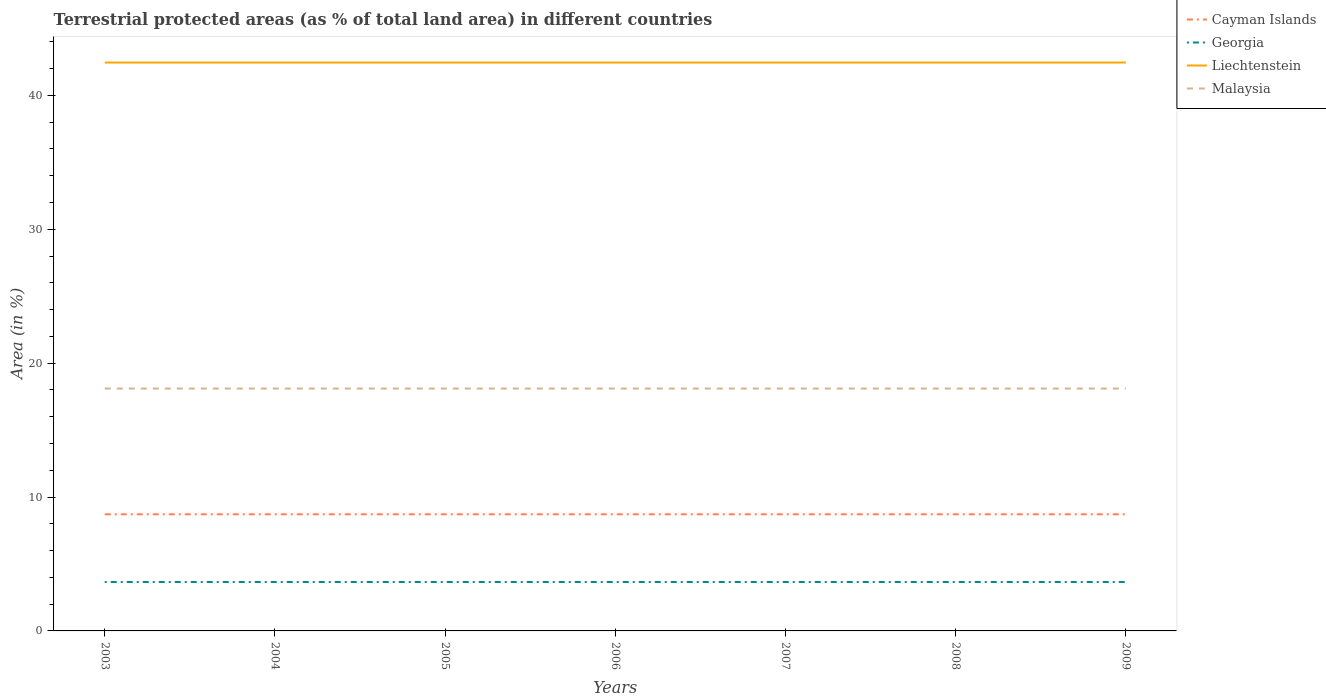Does the line corresponding to Malaysia intersect with the line corresponding to Georgia?
Provide a short and direct response. No. Across all years, what is the maximum percentage of terrestrial protected land in Malaysia?
Provide a succinct answer. 18.1. In which year was the percentage of terrestrial protected land in Georgia maximum?
Your response must be concise. 2003. Is the percentage of terrestrial protected land in Malaysia strictly greater than the percentage of terrestrial protected land in Cayman Islands over the years?
Offer a terse response. No. How many years are there in the graph?
Provide a succinct answer. 7. Does the graph contain any zero values?
Give a very brief answer. No. Does the graph contain grids?
Ensure brevity in your answer.  No. How are the legend labels stacked?
Provide a succinct answer. Vertical. What is the title of the graph?
Ensure brevity in your answer.  Terrestrial protected areas (as % of total land area) in different countries. What is the label or title of the X-axis?
Make the answer very short. Years. What is the label or title of the Y-axis?
Offer a terse response. Area (in %). What is the Area (in %) in Cayman Islands in 2003?
Make the answer very short. 8.71. What is the Area (in %) of Georgia in 2003?
Provide a short and direct response. 3.65. What is the Area (in %) of Liechtenstein in 2003?
Make the answer very short. 42.45. What is the Area (in %) of Malaysia in 2003?
Your response must be concise. 18.1. What is the Area (in %) of Cayman Islands in 2004?
Your answer should be very brief. 8.71. What is the Area (in %) of Georgia in 2004?
Provide a succinct answer. 3.65. What is the Area (in %) of Liechtenstein in 2004?
Give a very brief answer. 42.45. What is the Area (in %) in Malaysia in 2004?
Your answer should be very brief. 18.1. What is the Area (in %) in Cayman Islands in 2005?
Give a very brief answer. 8.71. What is the Area (in %) in Georgia in 2005?
Offer a very short reply. 3.65. What is the Area (in %) in Liechtenstein in 2005?
Provide a short and direct response. 42.45. What is the Area (in %) of Malaysia in 2005?
Give a very brief answer. 18.1. What is the Area (in %) in Cayman Islands in 2006?
Your answer should be very brief. 8.71. What is the Area (in %) in Georgia in 2006?
Provide a succinct answer. 3.65. What is the Area (in %) of Liechtenstein in 2006?
Provide a short and direct response. 42.45. What is the Area (in %) of Malaysia in 2006?
Ensure brevity in your answer.  18.1. What is the Area (in %) of Cayman Islands in 2007?
Ensure brevity in your answer.  8.71. What is the Area (in %) in Georgia in 2007?
Keep it short and to the point. 3.65. What is the Area (in %) of Liechtenstein in 2007?
Your answer should be very brief. 42.45. What is the Area (in %) in Malaysia in 2007?
Provide a short and direct response. 18.1. What is the Area (in %) in Cayman Islands in 2008?
Your answer should be very brief. 8.71. What is the Area (in %) in Georgia in 2008?
Give a very brief answer. 3.65. What is the Area (in %) of Liechtenstein in 2008?
Provide a short and direct response. 42.45. What is the Area (in %) of Malaysia in 2008?
Provide a short and direct response. 18.1. What is the Area (in %) of Cayman Islands in 2009?
Make the answer very short. 8.71. What is the Area (in %) in Georgia in 2009?
Make the answer very short. 3.65. What is the Area (in %) in Liechtenstein in 2009?
Give a very brief answer. 42.45. What is the Area (in %) of Malaysia in 2009?
Ensure brevity in your answer.  18.1. Across all years, what is the maximum Area (in %) of Cayman Islands?
Ensure brevity in your answer.  8.71. Across all years, what is the maximum Area (in %) of Georgia?
Make the answer very short. 3.65. Across all years, what is the maximum Area (in %) of Liechtenstein?
Your answer should be compact. 42.45. Across all years, what is the maximum Area (in %) in Malaysia?
Ensure brevity in your answer.  18.1. Across all years, what is the minimum Area (in %) of Cayman Islands?
Make the answer very short. 8.71. Across all years, what is the minimum Area (in %) of Georgia?
Offer a terse response. 3.65. Across all years, what is the minimum Area (in %) in Liechtenstein?
Provide a succinct answer. 42.45. Across all years, what is the minimum Area (in %) of Malaysia?
Make the answer very short. 18.1. What is the total Area (in %) in Cayman Islands in the graph?
Your answer should be compact. 60.97. What is the total Area (in %) of Georgia in the graph?
Ensure brevity in your answer.  25.57. What is the total Area (in %) of Liechtenstein in the graph?
Your answer should be compact. 297.15. What is the total Area (in %) in Malaysia in the graph?
Ensure brevity in your answer.  126.72. What is the difference between the Area (in %) of Cayman Islands in 2003 and that in 2004?
Give a very brief answer. 0. What is the difference between the Area (in %) in Georgia in 2003 and that in 2004?
Make the answer very short. 0. What is the difference between the Area (in %) of Cayman Islands in 2003 and that in 2005?
Provide a succinct answer. 0. What is the difference between the Area (in %) of Liechtenstein in 2003 and that in 2005?
Ensure brevity in your answer.  0. What is the difference between the Area (in %) in Malaysia in 2003 and that in 2005?
Provide a short and direct response. 0. What is the difference between the Area (in %) of Cayman Islands in 2003 and that in 2006?
Offer a terse response. 0. What is the difference between the Area (in %) in Georgia in 2003 and that in 2006?
Keep it short and to the point. 0. What is the difference between the Area (in %) in Malaysia in 2003 and that in 2006?
Make the answer very short. 0. What is the difference between the Area (in %) in Cayman Islands in 2003 and that in 2007?
Your answer should be compact. 0. What is the difference between the Area (in %) in Liechtenstein in 2003 and that in 2007?
Your answer should be very brief. 0. What is the difference between the Area (in %) in Malaysia in 2003 and that in 2007?
Give a very brief answer. 0. What is the difference between the Area (in %) in Cayman Islands in 2003 and that in 2008?
Your answer should be very brief. 0. What is the difference between the Area (in %) of Georgia in 2003 and that in 2008?
Make the answer very short. 0. What is the difference between the Area (in %) in Malaysia in 2003 and that in 2008?
Provide a short and direct response. 0. What is the difference between the Area (in %) of Georgia in 2003 and that in 2009?
Provide a short and direct response. 0. What is the difference between the Area (in %) of Cayman Islands in 2004 and that in 2005?
Make the answer very short. 0. What is the difference between the Area (in %) of Liechtenstein in 2004 and that in 2005?
Offer a terse response. 0. What is the difference between the Area (in %) in Georgia in 2004 and that in 2006?
Make the answer very short. 0. What is the difference between the Area (in %) of Liechtenstein in 2004 and that in 2006?
Your answer should be compact. 0. What is the difference between the Area (in %) in Liechtenstein in 2004 and that in 2007?
Your answer should be compact. 0. What is the difference between the Area (in %) in Cayman Islands in 2004 and that in 2008?
Provide a short and direct response. 0. What is the difference between the Area (in %) of Liechtenstein in 2004 and that in 2008?
Offer a very short reply. 0. What is the difference between the Area (in %) in Malaysia in 2004 and that in 2008?
Provide a succinct answer. 0. What is the difference between the Area (in %) of Malaysia in 2004 and that in 2009?
Your response must be concise. 0. What is the difference between the Area (in %) of Georgia in 2005 and that in 2006?
Provide a succinct answer. 0. What is the difference between the Area (in %) of Malaysia in 2005 and that in 2006?
Offer a very short reply. 0. What is the difference between the Area (in %) in Cayman Islands in 2005 and that in 2007?
Your answer should be compact. 0. What is the difference between the Area (in %) of Georgia in 2005 and that in 2007?
Offer a very short reply. 0. What is the difference between the Area (in %) in Malaysia in 2005 and that in 2007?
Provide a succinct answer. 0. What is the difference between the Area (in %) in Cayman Islands in 2005 and that in 2008?
Keep it short and to the point. 0. What is the difference between the Area (in %) of Georgia in 2005 and that in 2008?
Make the answer very short. 0. What is the difference between the Area (in %) of Liechtenstein in 2005 and that in 2008?
Make the answer very short. 0. What is the difference between the Area (in %) in Malaysia in 2005 and that in 2008?
Your response must be concise. 0. What is the difference between the Area (in %) of Georgia in 2005 and that in 2009?
Give a very brief answer. 0. What is the difference between the Area (in %) of Liechtenstein in 2005 and that in 2009?
Provide a short and direct response. 0. What is the difference between the Area (in %) of Malaysia in 2005 and that in 2009?
Keep it short and to the point. 0. What is the difference between the Area (in %) of Cayman Islands in 2006 and that in 2007?
Your response must be concise. 0. What is the difference between the Area (in %) in Georgia in 2006 and that in 2008?
Your answer should be very brief. 0. What is the difference between the Area (in %) in Georgia in 2006 and that in 2009?
Keep it short and to the point. 0. What is the difference between the Area (in %) of Liechtenstein in 2006 and that in 2009?
Your answer should be compact. 0. What is the difference between the Area (in %) in Malaysia in 2006 and that in 2009?
Ensure brevity in your answer.  0. What is the difference between the Area (in %) in Cayman Islands in 2007 and that in 2008?
Provide a succinct answer. 0. What is the difference between the Area (in %) of Liechtenstein in 2007 and that in 2008?
Offer a terse response. 0. What is the difference between the Area (in %) in Cayman Islands in 2007 and that in 2009?
Your response must be concise. 0. What is the difference between the Area (in %) in Liechtenstein in 2008 and that in 2009?
Ensure brevity in your answer.  0. What is the difference between the Area (in %) in Malaysia in 2008 and that in 2009?
Offer a terse response. 0. What is the difference between the Area (in %) of Cayman Islands in 2003 and the Area (in %) of Georgia in 2004?
Provide a succinct answer. 5.06. What is the difference between the Area (in %) of Cayman Islands in 2003 and the Area (in %) of Liechtenstein in 2004?
Keep it short and to the point. -33.74. What is the difference between the Area (in %) of Cayman Islands in 2003 and the Area (in %) of Malaysia in 2004?
Ensure brevity in your answer.  -9.39. What is the difference between the Area (in %) of Georgia in 2003 and the Area (in %) of Liechtenstein in 2004?
Ensure brevity in your answer.  -38.8. What is the difference between the Area (in %) of Georgia in 2003 and the Area (in %) of Malaysia in 2004?
Make the answer very short. -14.45. What is the difference between the Area (in %) of Liechtenstein in 2003 and the Area (in %) of Malaysia in 2004?
Your response must be concise. 24.35. What is the difference between the Area (in %) in Cayman Islands in 2003 and the Area (in %) in Georgia in 2005?
Make the answer very short. 5.06. What is the difference between the Area (in %) in Cayman Islands in 2003 and the Area (in %) in Liechtenstein in 2005?
Ensure brevity in your answer.  -33.74. What is the difference between the Area (in %) in Cayman Islands in 2003 and the Area (in %) in Malaysia in 2005?
Provide a short and direct response. -9.39. What is the difference between the Area (in %) of Georgia in 2003 and the Area (in %) of Liechtenstein in 2005?
Give a very brief answer. -38.8. What is the difference between the Area (in %) of Georgia in 2003 and the Area (in %) of Malaysia in 2005?
Provide a short and direct response. -14.45. What is the difference between the Area (in %) of Liechtenstein in 2003 and the Area (in %) of Malaysia in 2005?
Keep it short and to the point. 24.35. What is the difference between the Area (in %) in Cayman Islands in 2003 and the Area (in %) in Georgia in 2006?
Keep it short and to the point. 5.06. What is the difference between the Area (in %) of Cayman Islands in 2003 and the Area (in %) of Liechtenstein in 2006?
Offer a very short reply. -33.74. What is the difference between the Area (in %) in Cayman Islands in 2003 and the Area (in %) in Malaysia in 2006?
Your answer should be very brief. -9.39. What is the difference between the Area (in %) of Georgia in 2003 and the Area (in %) of Liechtenstein in 2006?
Provide a short and direct response. -38.8. What is the difference between the Area (in %) of Georgia in 2003 and the Area (in %) of Malaysia in 2006?
Give a very brief answer. -14.45. What is the difference between the Area (in %) of Liechtenstein in 2003 and the Area (in %) of Malaysia in 2006?
Your answer should be very brief. 24.35. What is the difference between the Area (in %) in Cayman Islands in 2003 and the Area (in %) in Georgia in 2007?
Provide a short and direct response. 5.06. What is the difference between the Area (in %) of Cayman Islands in 2003 and the Area (in %) of Liechtenstein in 2007?
Provide a short and direct response. -33.74. What is the difference between the Area (in %) of Cayman Islands in 2003 and the Area (in %) of Malaysia in 2007?
Provide a succinct answer. -9.39. What is the difference between the Area (in %) of Georgia in 2003 and the Area (in %) of Liechtenstein in 2007?
Your response must be concise. -38.8. What is the difference between the Area (in %) of Georgia in 2003 and the Area (in %) of Malaysia in 2007?
Keep it short and to the point. -14.45. What is the difference between the Area (in %) of Liechtenstein in 2003 and the Area (in %) of Malaysia in 2007?
Your answer should be compact. 24.35. What is the difference between the Area (in %) in Cayman Islands in 2003 and the Area (in %) in Georgia in 2008?
Provide a short and direct response. 5.06. What is the difference between the Area (in %) of Cayman Islands in 2003 and the Area (in %) of Liechtenstein in 2008?
Provide a short and direct response. -33.74. What is the difference between the Area (in %) of Cayman Islands in 2003 and the Area (in %) of Malaysia in 2008?
Your answer should be very brief. -9.39. What is the difference between the Area (in %) in Georgia in 2003 and the Area (in %) in Liechtenstein in 2008?
Provide a short and direct response. -38.8. What is the difference between the Area (in %) in Georgia in 2003 and the Area (in %) in Malaysia in 2008?
Keep it short and to the point. -14.45. What is the difference between the Area (in %) in Liechtenstein in 2003 and the Area (in %) in Malaysia in 2008?
Your answer should be compact. 24.35. What is the difference between the Area (in %) in Cayman Islands in 2003 and the Area (in %) in Georgia in 2009?
Your answer should be very brief. 5.06. What is the difference between the Area (in %) of Cayman Islands in 2003 and the Area (in %) of Liechtenstein in 2009?
Your response must be concise. -33.74. What is the difference between the Area (in %) in Cayman Islands in 2003 and the Area (in %) in Malaysia in 2009?
Offer a terse response. -9.39. What is the difference between the Area (in %) in Georgia in 2003 and the Area (in %) in Liechtenstein in 2009?
Offer a very short reply. -38.8. What is the difference between the Area (in %) of Georgia in 2003 and the Area (in %) of Malaysia in 2009?
Ensure brevity in your answer.  -14.45. What is the difference between the Area (in %) of Liechtenstein in 2003 and the Area (in %) of Malaysia in 2009?
Your answer should be very brief. 24.35. What is the difference between the Area (in %) in Cayman Islands in 2004 and the Area (in %) in Georgia in 2005?
Your answer should be compact. 5.06. What is the difference between the Area (in %) of Cayman Islands in 2004 and the Area (in %) of Liechtenstein in 2005?
Your answer should be compact. -33.74. What is the difference between the Area (in %) of Cayman Islands in 2004 and the Area (in %) of Malaysia in 2005?
Give a very brief answer. -9.39. What is the difference between the Area (in %) of Georgia in 2004 and the Area (in %) of Liechtenstein in 2005?
Provide a short and direct response. -38.8. What is the difference between the Area (in %) of Georgia in 2004 and the Area (in %) of Malaysia in 2005?
Make the answer very short. -14.45. What is the difference between the Area (in %) of Liechtenstein in 2004 and the Area (in %) of Malaysia in 2005?
Provide a short and direct response. 24.35. What is the difference between the Area (in %) in Cayman Islands in 2004 and the Area (in %) in Georgia in 2006?
Provide a succinct answer. 5.06. What is the difference between the Area (in %) of Cayman Islands in 2004 and the Area (in %) of Liechtenstein in 2006?
Make the answer very short. -33.74. What is the difference between the Area (in %) of Cayman Islands in 2004 and the Area (in %) of Malaysia in 2006?
Keep it short and to the point. -9.39. What is the difference between the Area (in %) in Georgia in 2004 and the Area (in %) in Liechtenstein in 2006?
Make the answer very short. -38.8. What is the difference between the Area (in %) in Georgia in 2004 and the Area (in %) in Malaysia in 2006?
Your response must be concise. -14.45. What is the difference between the Area (in %) in Liechtenstein in 2004 and the Area (in %) in Malaysia in 2006?
Offer a terse response. 24.35. What is the difference between the Area (in %) of Cayman Islands in 2004 and the Area (in %) of Georgia in 2007?
Ensure brevity in your answer.  5.06. What is the difference between the Area (in %) of Cayman Islands in 2004 and the Area (in %) of Liechtenstein in 2007?
Keep it short and to the point. -33.74. What is the difference between the Area (in %) of Cayman Islands in 2004 and the Area (in %) of Malaysia in 2007?
Your answer should be very brief. -9.39. What is the difference between the Area (in %) in Georgia in 2004 and the Area (in %) in Liechtenstein in 2007?
Give a very brief answer. -38.8. What is the difference between the Area (in %) of Georgia in 2004 and the Area (in %) of Malaysia in 2007?
Offer a very short reply. -14.45. What is the difference between the Area (in %) of Liechtenstein in 2004 and the Area (in %) of Malaysia in 2007?
Make the answer very short. 24.35. What is the difference between the Area (in %) in Cayman Islands in 2004 and the Area (in %) in Georgia in 2008?
Your answer should be compact. 5.06. What is the difference between the Area (in %) of Cayman Islands in 2004 and the Area (in %) of Liechtenstein in 2008?
Ensure brevity in your answer.  -33.74. What is the difference between the Area (in %) in Cayman Islands in 2004 and the Area (in %) in Malaysia in 2008?
Offer a terse response. -9.39. What is the difference between the Area (in %) of Georgia in 2004 and the Area (in %) of Liechtenstein in 2008?
Provide a succinct answer. -38.8. What is the difference between the Area (in %) in Georgia in 2004 and the Area (in %) in Malaysia in 2008?
Your answer should be compact. -14.45. What is the difference between the Area (in %) in Liechtenstein in 2004 and the Area (in %) in Malaysia in 2008?
Keep it short and to the point. 24.35. What is the difference between the Area (in %) in Cayman Islands in 2004 and the Area (in %) in Georgia in 2009?
Your answer should be compact. 5.06. What is the difference between the Area (in %) of Cayman Islands in 2004 and the Area (in %) of Liechtenstein in 2009?
Keep it short and to the point. -33.74. What is the difference between the Area (in %) in Cayman Islands in 2004 and the Area (in %) in Malaysia in 2009?
Make the answer very short. -9.39. What is the difference between the Area (in %) in Georgia in 2004 and the Area (in %) in Liechtenstein in 2009?
Ensure brevity in your answer.  -38.8. What is the difference between the Area (in %) of Georgia in 2004 and the Area (in %) of Malaysia in 2009?
Offer a very short reply. -14.45. What is the difference between the Area (in %) of Liechtenstein in 2004 and the Area (in %) of Malaysia in 2009?
Make the answer very short. 24.35. What is the difference between the Area (in %) in Cayman Islands in 2005 and the Area (in %) in Georgia in 2006?
Your answer should be compact. 5.06. What is the difference between the Area (in %) of Cayman Islands in 2005 and the Area (in %) of Liechtenstein in 2006?
Provide a succinct answer. -33.74. What is the difference between the Area (in %) in Cayman Islands in 2005 and the Area (in %) in Malaysia in 2006?
Provide a succinct answer. -9.39. What is the difference between the Area (in %) of Georgia in 2005 and the Area (in %) of Liechtenstein in 2006?
Provide a succinct answer. -38.8. What is the difference between the Area (in %) of Georgia in 2005 and the Area (in %) of Malaysia in 2006?
Give a very brief answer. -14.45. What is the difference between the Area (in %) in Liechtenstein in 2005 and the Area (in %) in Malaysia in 2006?
Your answer should be very brief. 24.35. What is the difference between the Area (in %) of Cayman Islands in 2005 and the Area (in %) of Georgia in 2007?
Your answer should be compact. 5.06. What is the difference between the Area (in %) of Cayman Islands in 2005 and the Area (in %) of Liechtenstein in 2007?
Your response must be concise. -33.74. What is the difference between the Area (in %) of Cayman Islands in 2005 and the Area (in %) of Malaysia in 2007?
Offer a very short reply. -9.39. What is the difference between the Area (in %) of Georgia in 2005 and the Area (in %) of Liechtenstein in 2007?
Your answer should be very brief. -38.8. What is the difference between the Area (in %) in Georgia in 2005 and the Area (in %) in Malaysia in 2007?
Ensure brevity in your answer.  -14.45. What is the difference between the Area (in %) in Liechtenstein in 2005 and the Area (in %) in Malaysia in 2007?
Your answer should be compact. 24.35. What is the difference between the Area (in %) in Cayman Islands in 2005 and the Area (in %) in Georgia in 2008?
Keep it short and to the point. 5.06. What is the difference between the Area (in %) in Cayman Islands in 2005 and the Area (in %) in Liechtenstein in 2008?
Make the answer very short. -33.74. What is the difference between the Area (in %) of Cayman Islands in 2005 and the Area (in %) of Malaysia in 2008?
Make the answer very short. -9.39. What is the difference between the Area (in %) of Georgia in 2005 and the Area (in %) of Liechtenstein in 2008?
Give a very brief answer. -38.8. What is the difference between the Area (in %) in Georgia in 2005 and the Area (in %) in Malaysia in 2008?
Provide a short and direct response. -14.45. What is the difference between the Area (in %) in Liechtenstein in 2005 and the Area (in %) in Malaysia in 2008?
Your answer should be compact. 24.35. What is the difference between the Area (in %) of Cayman Islands in 2005 and the Area (in %) of Georgia in 2009?
Your answer should be compact. 5.06. What is the difference between the Area (in %) of Cayman Islands in 2005 and the Area (in %) of Liechtenstein in 2009?
Provide a short and direct response. -33.74. What is the difference between the Area (in %) of Cayman Islands in 2005 and the Area (in %) of Malaysia in 2009?
Give a very brief answer. -9.39. What is the difference between the Area (in %) in Georgia in 2005 and the Area (in %) in Liechtenstein in 2009?
Provide a short and direct response. -38.8. What is the difference between the Area (in %) in Georgia in 2005 and the Area (in %) in Malaysia in 2009?
Your answer should be compact. -14.45. What is the difference between the Area (in %) in Liechtenstein in 2005 and the Area (in %) in Malaysia in 2009?
Give a very brief answer. 24.35. What is the difference between the Area (in %) of Cayman Islands in 2006 and the Area (in %) of Georgia in 2007?
Make the answer very short. 5.06. What is the difference between the Area (in %) in Cayman Islands in 2006 and the Area (in %) in Liechtenstein in 2007?
Ensure brevity in your answer.  -33.74. What is the difference between the Area (in %) in Cayman Islands in 2006 and the Area (in %) in Malaysia in 2007?
Your answer should be very brief. -9.39. What is the difference between the Area (in %) in Georgia in 2006 and the Area (in %) in Liechtenstein in 2007?
Provide a short and direct response. -38.8. What is the difference between the Area (in %) of Georgia in 2006 and the Area (in %) of Malaysia in 2007?
Provide a short and direct response. -14.45. What is the difference between the Area (in %) of Liechtenstein in 2006 and the Area (in %) of Malaysia in 2007?
Provide a succinct answer. 24.35. What is the difference between the Area (in %) in Cayman Islands in 2006 and the Area (in %) in Georgia in 2008?
Provide a short and direct response. 5.06. What is the difference between the Area (in %) in Cayman Islands in 2006 and the Area (in %) in Liechtenstein in 2008?
Offer a very short reply. -33.74. What is the difference between the Area (in %) of Cayman Islands in 2006 and the Area (in %) of Malaysia in 2008?
Provide a short and direct response. -9.39. What is the difference between the Area (in %) in Georgia in 2006 and the Area (in %) in Liechtenstein in 2008?
Offer a terse response. -38.8. What is the difference between the Area (in %) in Georgia in 2006 and the Area (in %) in Malaysia in 2008?
Keep it short and to the point. -14.45. What is the difference between the Area (in %) in Liechtenstein in 2006 and the Area (in %) in Malaysia in 2008?
Offer a very short reply. 24.35. What is the difference between the Area (in %) of Cayman Islands in 2006 and the Area (in %) of Georgia in 2009?
Provide a short and direct response. 5.06. What is the difference between the Area (in %) in Cayman Islands in 2006 and the Area (in %) in Liechtenstein in 2009?
Keep it short and to the point. -33.74. What is the difference between the Area (in %) of Cayman Islands in 2006 and the Area (in %) of Malaysia in 2009?
Provide a succinct answer. -9.39. What is the difference between the Area (in %) in Georgia in 2006 and the Area (in %) in Liechtenstein in 2009?
Make the answer very short. -38.8. What is the difference between the Area (in %) of Georgia in 2006 and the Area (in %) of Malaysia in 2009?
Provide a succinct answer. -14.45. What is the difference between the Area (in %) of Liechtenstein in 2006 and the Area (in %) of Malaysia in 2009?
Offer a very short reply. 24.35. What is the difference between the Area (in %) in Cayman Islands in 2007 and the Area (in %) in Georgia in 2008?
Your answer should be very brief. 5.06. What is the difference between the Area (in %) of Cayman Islands in 2007 and the Area (in %) of Liechtenstein in 2008?
Provide a succinct answer. -33.74. What is the difference between the Area (in %) in Cayman Islands in 2007 and the Area (in %) in Malaysia in 2008?
Keep it short and to the point. -9.39. What is the difference between the Area (in %) of Georgia in 2007 and the Area (in %) of Liechtenstein in 2008?
Offer a terse response. -38.8. What is the difference between the Area (in %) in Georgia in 2007 and the Area (in %) in Malaysia in 2008?
Offer a very short reply. -14.45. What is the difference between the Area (in %) in Liechtenstein in 2007 and the Area (in %) in Malaysia in 2008?
Make the answer very short. 24.35. What is the difference between the Area (in %) of Cayman Islands in 2007 and the Area (in %) of Georgia in 2009?
Ensure brevity in your answer.  5.06. What is the difference between the Area (in %) of Cayman Islands in 2007 and the Area (in %) of Liechtenstein in 2009?
Give a very brief answer. -33.74. What is the difference between the Area (in %) of Cayman Islands in 2007 and the Area (in %) of Malaysia in 2009?
Offer a terse response. -9.39. What is the difference between the Area (in %) of Georgia in 2007 and the Area (in %) of Liechtenstein in 2009?
Ensure brevity in your answer.  -38.8. What is the difference between the Area (in %) in Georgia in 2007 and the Area (in %) in Malaysia in 2009?
Provide a short and direct response. -14.45. What is the difference between the Area (in %) of Liechtenstein in 2007 and the Area (in %) of Malaysia in 2009?
Your answer should be compact. 24.35. What is the difference between the Area (in %) of Cayman Islands in 2008 and the Area (in %) of Georgia in 2009?
Give a very brief answer. 5.06. What is the difference between the Area (in %) of Cayman Islands in 2008 and the Area (in %) of Liechtenstein in 2009?
Your answer should be very brief. -33.74. What is the difference between the Area (in %) of Cayman Islands in 2008 and the Area (in %) of Malaysia in 2009?
Your answer should be very brief. -9.39. What is the difference between the Area (in %) in Georgia in 2008 and the Area (in %) in Liechtenstein in 2009?
Your answer should be compact. -38.8. What is the difference between the Area (in %) of Georgia in 2008 and the Area (in %) of Malaysia in 2009?
Offer a very short reply. -14.45. What is the difference between the Area (in %) of Liechtenstein in 2008 and the Area (in %) of Malaysia in 2009?
Provide a succinct answer. 24.35. What is the average Area (in %) in Cayman Islands per year?
Ensure brevity in your answer.  8.71. What is the average Area (in %) of Georgia per year?
Provide a succinct answer. 3.65. What is the average Area (in %) of Liechtenstein per year?
Keep it short and to the point. 42.45. What is the average Area (in %) in Malaysia per year?
Provide a short and direct response. 18.1. In the year 2003, what is the difference between the Area (in %) of Cayman Islands and Area (in %) of Georgia?
Offer a terse response. 5.06. In the year 2003, what is the difference between the Area (in %) in Cayman Islands and Area (in %) in Liechtenstein?
Offer a terse response. -33.74. In the year 2003, what is the difference between the Area (in %) in Cayman Islands and Area (in %) in Malaysia?
Provide a succinct answer. -9.39. In the year 2003, what is the difference between the Area (in %) of Georgia and Area (in %) of Liechtenstein?
Offer a terse response. -38.8. In the year 2003, what is the difference between the Area (in %) of Georgia and Area (in %) of Malaysia?
Provide a succinct answer. -14.45. In the year 2003, what is the difference between the Area (in %) in Liechtenstein and Area (in %) in Malaysia?
Offer a very short reply. 24.35. In the year 2004, what is the difference between the Area (in %) of Cayman Islands and Area (in %) of Georgia?
Your answer should be compact. 5.06. In the year 2004, what is the difference between the Area (in %) of Cayman Islands and Area (in %) of Liechtenstein?
Ensure brevity in your answer.  -33.74. In the year 2004, what is the difference between the Area (in %) in Cayman Islands and Area (in %) in Malaysia?
Make the answer very short. -9.39. In the year 2004, what is the difference between the Area (in %) of Georgia and Area (in %) of Liechtenstein?
Your response must be concise. -38.8. In the year 2004, what is the difference between the Area (in %) of Georgia and Area (in %) of Malaysia?
Offer a terse response. -14.45. In the year 2004, what is the difference between the Area (in %) in Liechtenstein and Area (in %) in Malaysia?
Give a very brief answer. 24.35. In the year 2005, what is the difference between the Area (in %) of Cayman Islands and Area (in %) of Georgia?
Give a very brief answer. 5.06. In the year 2005, what is the difference between the Area (in %) in Cayman Islands and Area (in %) in Liechtenstein?
Provide a short and direct response. -33.74. In the year 2005, what is the difference between the Area (in %) in Cayman Islands and Area (in %) in Malaysia?
Make the answer very short. -9.39. In the year 2005, what is the difference between the Area (in %) of Georgia and Area (in %) of Liechtenstein?
Give a very brief answer. -38.8. In the year 2005, what is the difference between the Area (in %) of Georgia and Area (in %) of Malaysia?
Offer a terse response. -14.45. In the year 2005, what is the difference between the Area (in %) in Liechtenstein and Area (in %) in Malaysia?
Ensure brevity in your answer.  24.35. In the year 2006, what is the difference between the Area (in %) in Cayman Islands and Area (in %) in Georgia?
Your response must be concise. 5.06. In the year 2006, what is the difference between the Area (in %) of Cayman Islands and Area (in %) of Liechtenstein?
Ensure brevity in your answer.  -33.74. In the year 2006, what is the difference between the Area (in %) in Cayman Islands and Area (in %) in Malaysia?
Ensure brevity in your answer.  -9.39. In the year 2006, what is the difference between the Area (in %) of Georgia and Area (in %) of Liechtenstein?
Give a very brief answer. -38.8. In the year 2006, what is the difference between the Area (in %) of Georgia and Area (in %) of Malaysia?
Your response must be concise. -14.45. In the year 2006, what is the difference between the Area (in %) in Liechtenstein and Area (in %) in Malaysia?
Offer a terse response. 24.35. In the year 2007, what is the difference between the Area (in %) of Cayman Islands and Area (in %) of Georgia?
Your answer should be very brief. 5.06. In the year 2007, what is the difference between the Area (in %) in Cayman Islands and Area (in %) in Liechtenstein?
Keep it short and to the point. -33.74. In the year 2007, what is the difference between the Area (in %) in Cayman Islands and Area (in %) in Malaysia?
Make the answer very short. -9.39. In the year 2007, what is the difference between the Area (in %) in Georgia and Area (in %) in Liechtenstein?
Give a very brief answer. -38.8. In the year 2007, what is the difference between the Area (in %) of Georgia and Area (in %) of Malaysia?
Provide a succinct answer. -14.45. In the year 2007, what is the difference between the Area (in %) in Liechtenstein and Area (in %) in Malaysia?
Offer a very short reply. 24.35. In the year 2008, what is the difference between the Area (in %) in Cayman Islands and Area (in %) in Georgia?
Offer a very short reply. 5.06. In the year 2008, what is the difference between the Area (in %) in Cayman Islands and Area (in %) in Liechtenstein?
Your answer should be compact. -33.74. In the year 2008, what is the difference between the Area (in %) in Cayman Islands and Area (in %) in Malaysia?
Your answer should be compact. -9.39. In the year 2008, what is the difference between the Area (in %) of Georgia and Area (in %) of Liechtenstein?
Ensure brevity in your answer.  -38.8. In the year 2008, what is the difference between the Area (in %) in Georgia and Area (in %) in Malaysia?
Provide a succinct answer. -14.45. In the year 2008, what is the difference between the Area (in %) of Liechtenstein and Area (in %) of Malaysia?
Keep it short and to the point. 24.35. In the year 2009, what is the difference between the Area (in %) in Cayman Islands and Area (in %) in Georgia?
Your response must be concise. 5.06. In the year 2009, what is the difference between the Area (in %) of Cayman Islands and Area (in %) of Liechtenstein?
Your answer should be very brief. -33.74. In the year 2009, what is the difference between the Area (in %) of Cayman Islands and Area (in %) of Malaysia?
Provide a succinct answer. -9.39. In the year 2009, what is the difference between the Area (in %) in Georgia and Area (in %) in Liechtenstein?
Your answer should be compact. -38.8. In the year 2009, what is the difference between the Area (in %) of Georgia and Area (in %) of Malaysia?
Provide a succinct answer. -14.45. In the year 2009, what is the difference between the Area (in %) in Liechtenstein and Area (in %) in Malaysia?
Your answer should be very brief. 24.35. What is the ratio of the Area (in %) of Cayman Islands in 2003 to that in 2004?
Your response must be concise. 1. What is the ratio of the Area (in %) of Georgia in 2003 to that in 2004?
Your answer should be compact. 1. What is the ratio of the Area (in %) in Malaysia in 2003 to that in 2005?
Your answer should be very brief. 1. What is the ratio of the Area (in %) in Cayman Islands in 2003 to that in 2006?
Offer a very short reply. 1. What is the ratio of the Area (in %) of Liechtenstein in 2003 to that in 2006?
Your answer should be very brief. 1. What is the ratio of the Area (in %) in Liechtenstein in 2003 to that in 2007?
Your response must be concise. 1. What is the ratio of the Area (in %) in Cayman Islands in 2003 to that in 2008?
Give a very brief answer. 1. What is the ratio of the Area (in %) of Liechtenstein in 2003 to that in 2008?
Your answer should be compact. 1. What is the ratio of the Area (in %) of Georgia in 2003 to that in 2009?
Keep it short and to the point. 1. What is the ratio of the Area (in %) in Malaysia in 2003 to that in 2009?
Offer a very short reply. 1. What is the ratio of the Area (in %) of Malaysia in 2004 to that in 2005?
Give a very brief answer. 1. What is the ratio of the Area (in %) of Cayman Islands in 2004 to that in 2006?
Provide a succinct answer. 1. What is the ratio of the Area (in %) in Liechtenstein in 2004 to that in 2006?
Provide a short and direct response. 1. What is the ratio of the Area (in %) in Liechtenstein in 2004 to that in 2007?
Your answer should be very brief. 1. What is the ratio of the Area (in %) of Malaysia in 2004 to that in 2007?
Keep it short and to the point. 1. What is the ratio of the Area (in %) in Georgia in 2004 to that in 2008?
Offer a terse response. 1. What is the ratio of the Area (in %) of Liechtenstein in 2004 to that in 2008?
Provide a succinct answer. 1. What is the ratio of the Area (in %) in Malaysia in 2004 to that in 2008?
Your answer should be very brief. 1. What is the ratio of the Area (in %) in Liechtenstein in 2004 to that in 2009?
Give a very brief answer. 1. What is the ratio of the Area (in %) in Malaysia in 2004 to that in 2009?
Your answer should be very brief. 1. What is the ratio of the Area (in %) in Cayman Islands in 2005 to that in 2006?
Offer a terse response. 1. What is the ratio of the Area (in %) in Georgia in 2005 to that in 2006?
Give a very brief answer. 1. What is the ratio of the Area (in %) in Liechtenstein in 2005 to that in 2006?
Offer a terse response. 1. What is the ratio of the Area (in %) of Malaysia in 2005 to that in 2007?
Keep it short and to the point. 1. What is the ratio of the Area (in %) in Liechtenstein in 2005 to that in 2008?
Your answer should be very brief. 1. What is the ratio of the Area (in %) of Cayman Islands in 2005 to that in 2009?
Provide a short and direct response. 1. What is the ratio of the Area (in %) of Cayman Islands in 2006 to that in 2007?
Provide a short and direct response. 1. What is the ratio of the Area (in %) in Malaysia in 2006 to that in 2007?
Give a very brief answer. 1. What is the ratio of the Area (in %) in Georgia in 2006 to that in 2008?
Make the answer very short. 1. What is the ratio of the Area (in %) of Liechtenstein in 2006 to that in 2008?
Your answer should be very brief. 1. What is the ratio of the Area (in %) in Malaysia in 2006 to that in 2008?
Offer a terse response. 1. What is the ratio of the Area (in %) of Georgia in 2006 to that in 2009?
Your answer should be very brief. 1. What is the ratio of the Area (in %) of Georgia in 2007 to that in 2008?
Provide a succinct answer. 1. What is the ratio of the Area (in %) of Liechtenstein in 2007 to that in 2008?
Your response must be concise. 1. What is the ratio of the Area (in %) in Cayman Islands in 2007 to that in 2009?
Offer a terse response. 1. What is the ratio of the Area (in %) in Georgia in 2007 to that in 2009?
Keep it short and to the point. 1. What is the ratio of the Area (in %) in Cayman Islands in 2008 to that in 2009?
Keep it short and to the point. 1. What is the ratio of the Area (in %) of Georgia in 2008 to that in 2009?
Keep it short and to the point. 1. What is the ratio of the Area (in %) of Liechtenstein in 2008 to that in 2009?
Ensure brevity in your answer.  1. What is the difference between the highest and the second highest Area (in %) of Malaysia?
Offer a very short reply. 0. What is the difference between the highest and the lowest Area (in %) in Georgia?
Give a very brief answer. 0. What is the difference between the highest and the lowest Area (in %) of Liechtenstein?
Provide a short and direct response. 0. What is the difference between the highest and the lowest Area (in %) in Malaysia?
Provide a short and direct response. 0. 